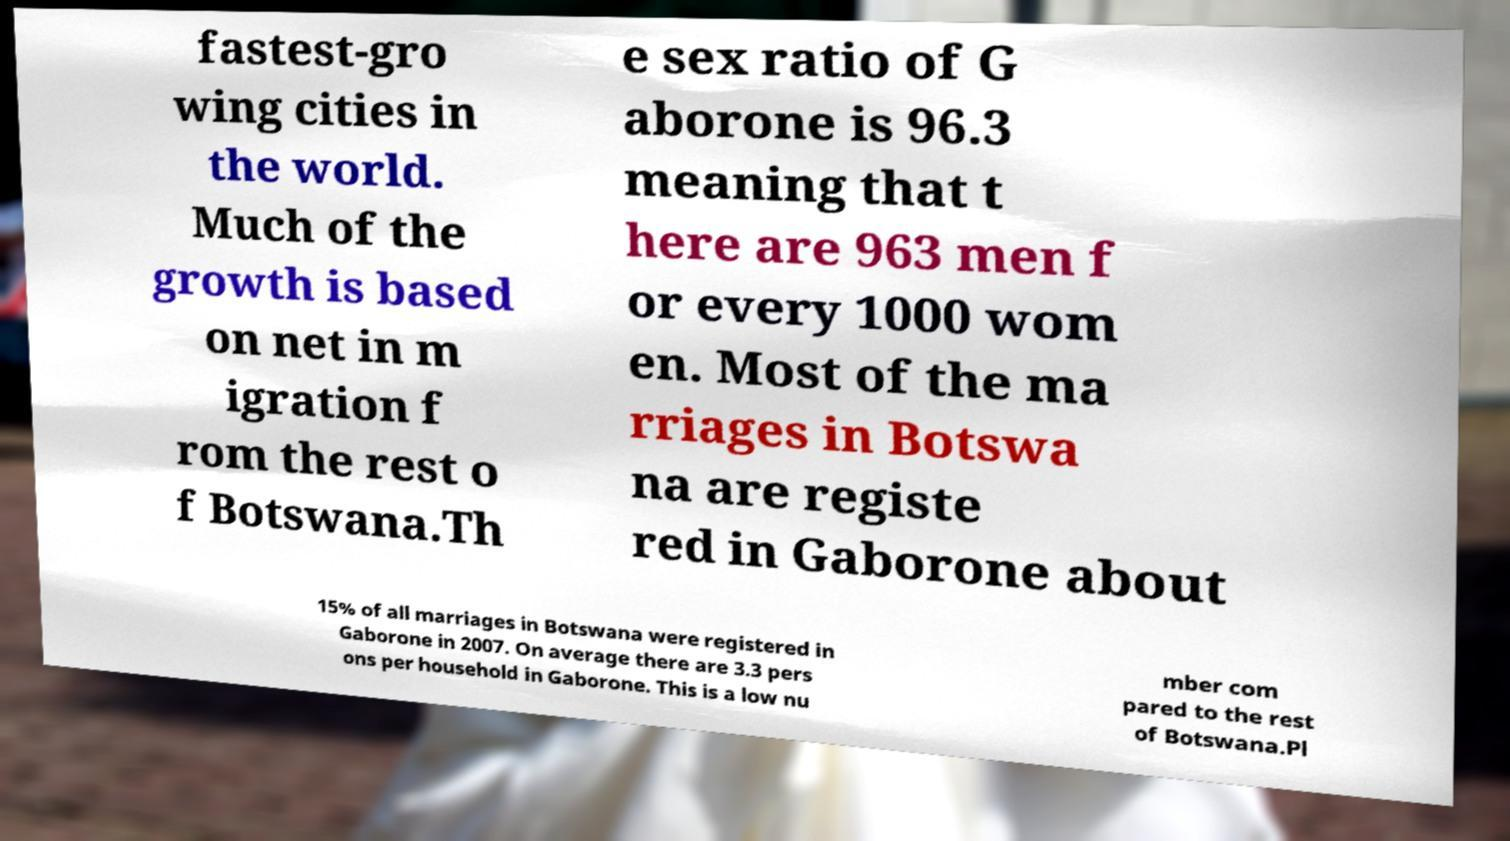Can you read and provide the text displayed in the image?This photo seems to have some interesting text. Can you extract and type it out for me? fastest-gro wing cities in the world. Much of the growth is based on net in m igration f rom the rest o f Botswana.Th e sex ratio of G aborone is 96.3 meaning that t here are 963 men f or every 1000 wom en. Most of the ma rriages in Botswa na are registe red in Gaborone about 15% of all marriages in Botswana were registered in Gaborone in 2007. On average there are 3.3 pers ons per household in Gaborone. This is a low nu mber com pared to the rest of Botswana.Pl 